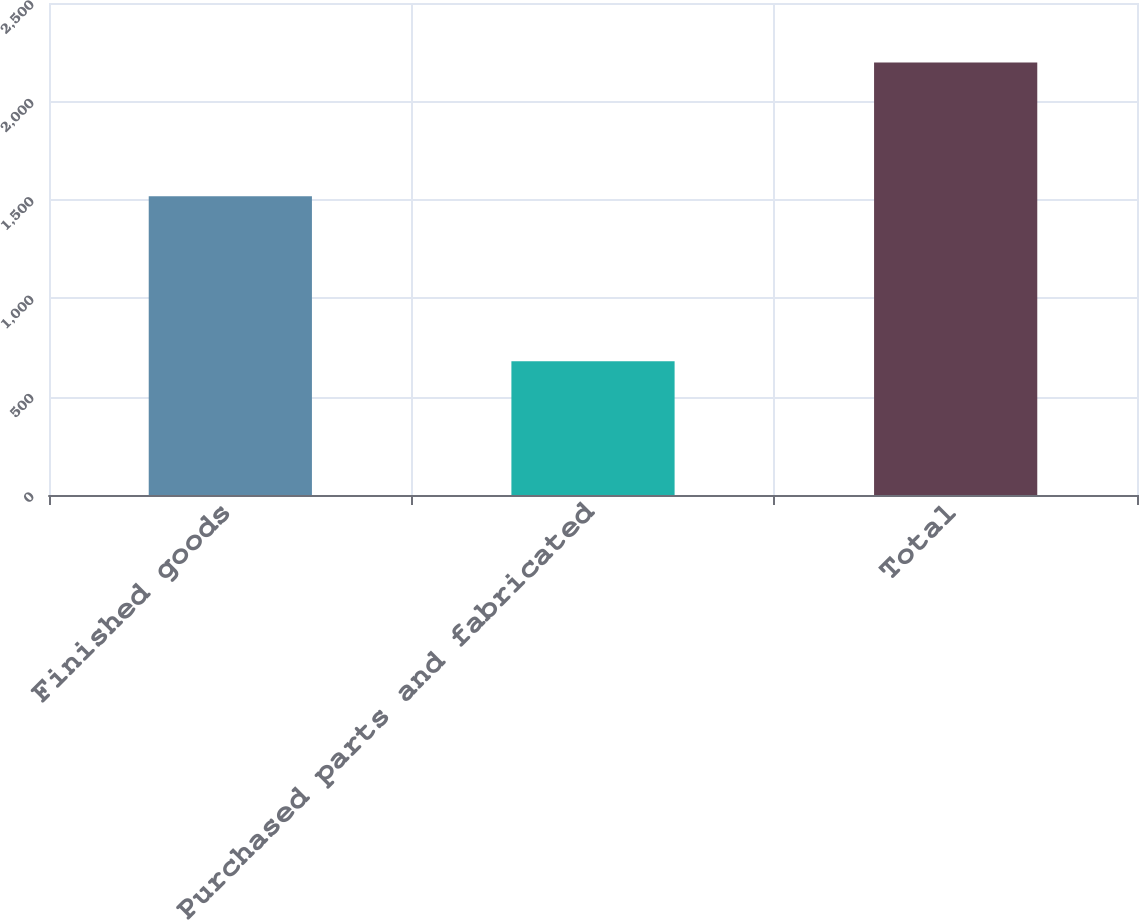Convert chart to OTSL. <chart><loc_0><loc_0><loc_500><loc_500><bar_chart><fcel>Finished goods<fcel>Purchased parts and fabricated<fcel>Total<nl><fcel>1518<fcel>680<fcel>2198<nl></chart> 